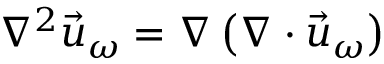Convert formula to latex. <formula><loc_0><loc_0><loc_500><loc_500>\nabla ^ { 2 } \vec { u } _ { \omega } = \nabla \left ( \nabla \cdot \vec { u } _ { \omega } \right )</formula> 